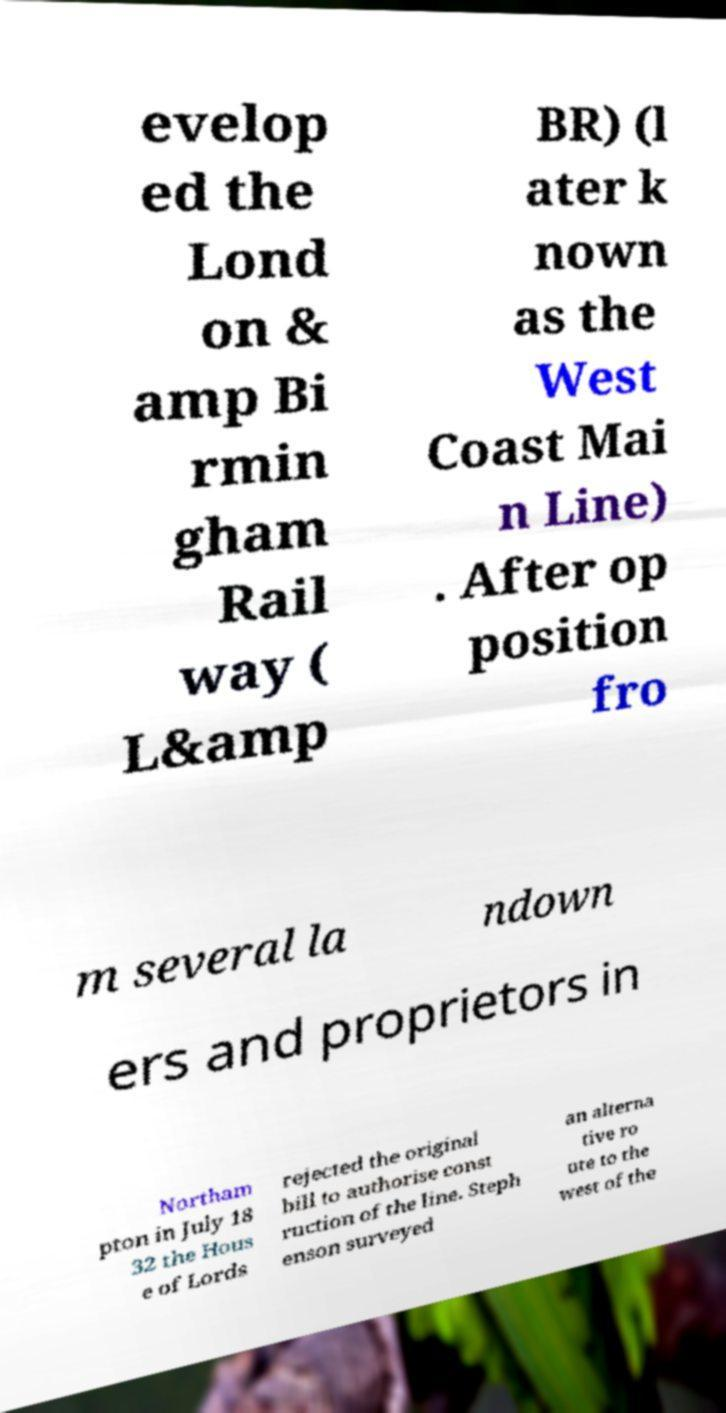Please read and relay the text visible in this image. What does it say? evelop ed the Lond on & amp Bi rmin gham Rail way ( L&amp BR) (l ater k nown as the West Coast Mai n Line) . After op position fro m several la ndown ers and proprietors in Northam pton in July 18 32 the Hous e of Lords rejected the original bill to authorise const ruction of the line. Steph enson surveyed an alterna tive ro ute to the west of the 